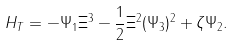Convert formula to latex. <formula><loc_0><loc_0><loc_500><loc_500>H _ { T } = - \Psi _ { 1 } \Xi ^ { 3 } - \frac { 1 } { 2 } \Xi ^ { 2 } ( \Psi _ { 3 } ) ^ { 2 } + \zeta \Psi _ { 2 } .</formula> 